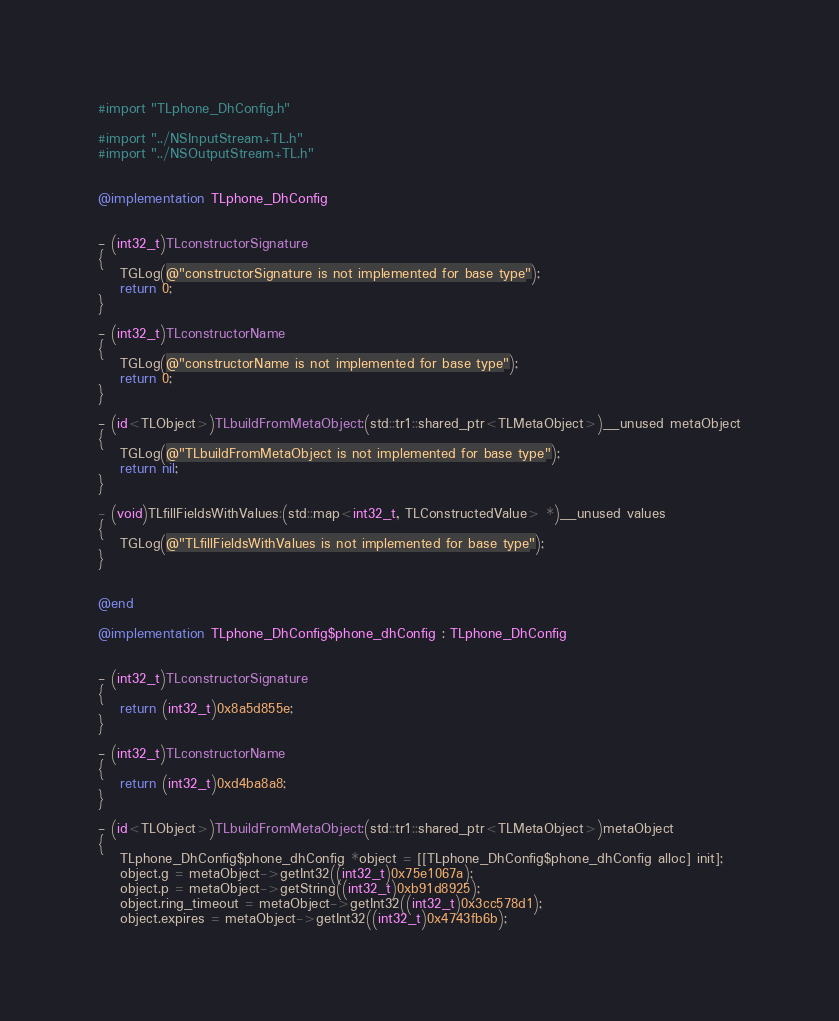<code> <loc_0><loc_0><loc_500><loc_500><_ObjectiveC_>#import "TLphone_DhConfig.h"

#import "../NSInputStream+TL.h"
#import "../NSOutputStream+TL.h"


@implementation TLphone_DhConfig


- (int32_t)TLconstructorSignature
{
    TGLog(@"constructorSignature is not implemented for base type");
    return 0;
}

- (int32_t)TLconstructorName
{
    TGLog(@"constructorName is not implemented for base type");
    return 0;
}

- (id<TLObject>)TLbuildFromMetaObject:(std::tr1::shared_ptr<TLMetaObject>)__unused metaObject
{
    TGLog(@"TLbuildFromMetaObject is not implemented for base type");
    return nil;
}

- (void)TLfillFieldsWithValues:(std::map<int32_t, TLConstructedValue> *)__unused values
{
    TGLog(@"TLfillFieldsWithValues is not implemented for base type");
}


@end

@implementation TLphone_DhConfig$phone_dhConfig : TLphone_DhConfig


- (int32_t)TLconstructorSignature
{
    return (int32_t)0x8a5d855e;
}

- (int32_t)TLconstructorName
{
    return (int32_t)0xd4ba8a8;
}

- (id<TLObject>)TLbuildFromMetaObject:(std::tr1::shared_ptr<TLMetaObject>)metaObject
{
    TLphone_DhConfig$phone_dhConfig *object = [[TLphone_DhConfig$phone_dhConfig alloc] init];
    object.g = metaObject->getInt32((int32_t)0x75e1067a);
    object.p = metaObject->getString((int32_t)0xb91d8925);
    object.ring_timeout = metaObject->getInt32((int32_t)0x3cc578d1);
    object.expires = metaObject->getInt32((int32_t)0x4743fb6b);</code> 